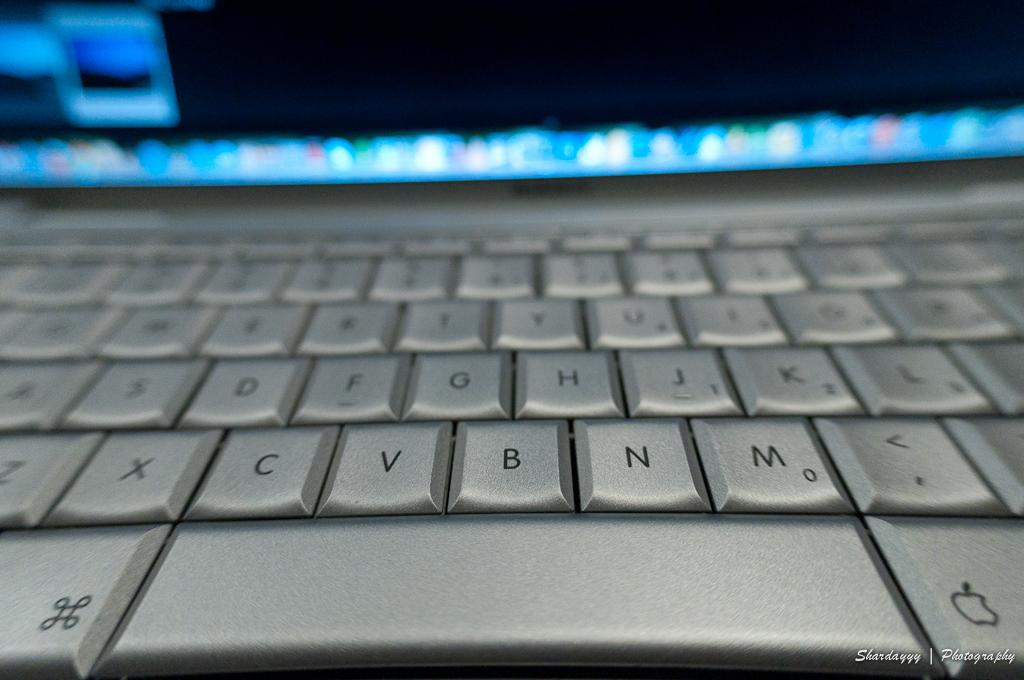<image>
Relay a brief, clear account of the picture shown. a silver key board with letters such as C, V and B 